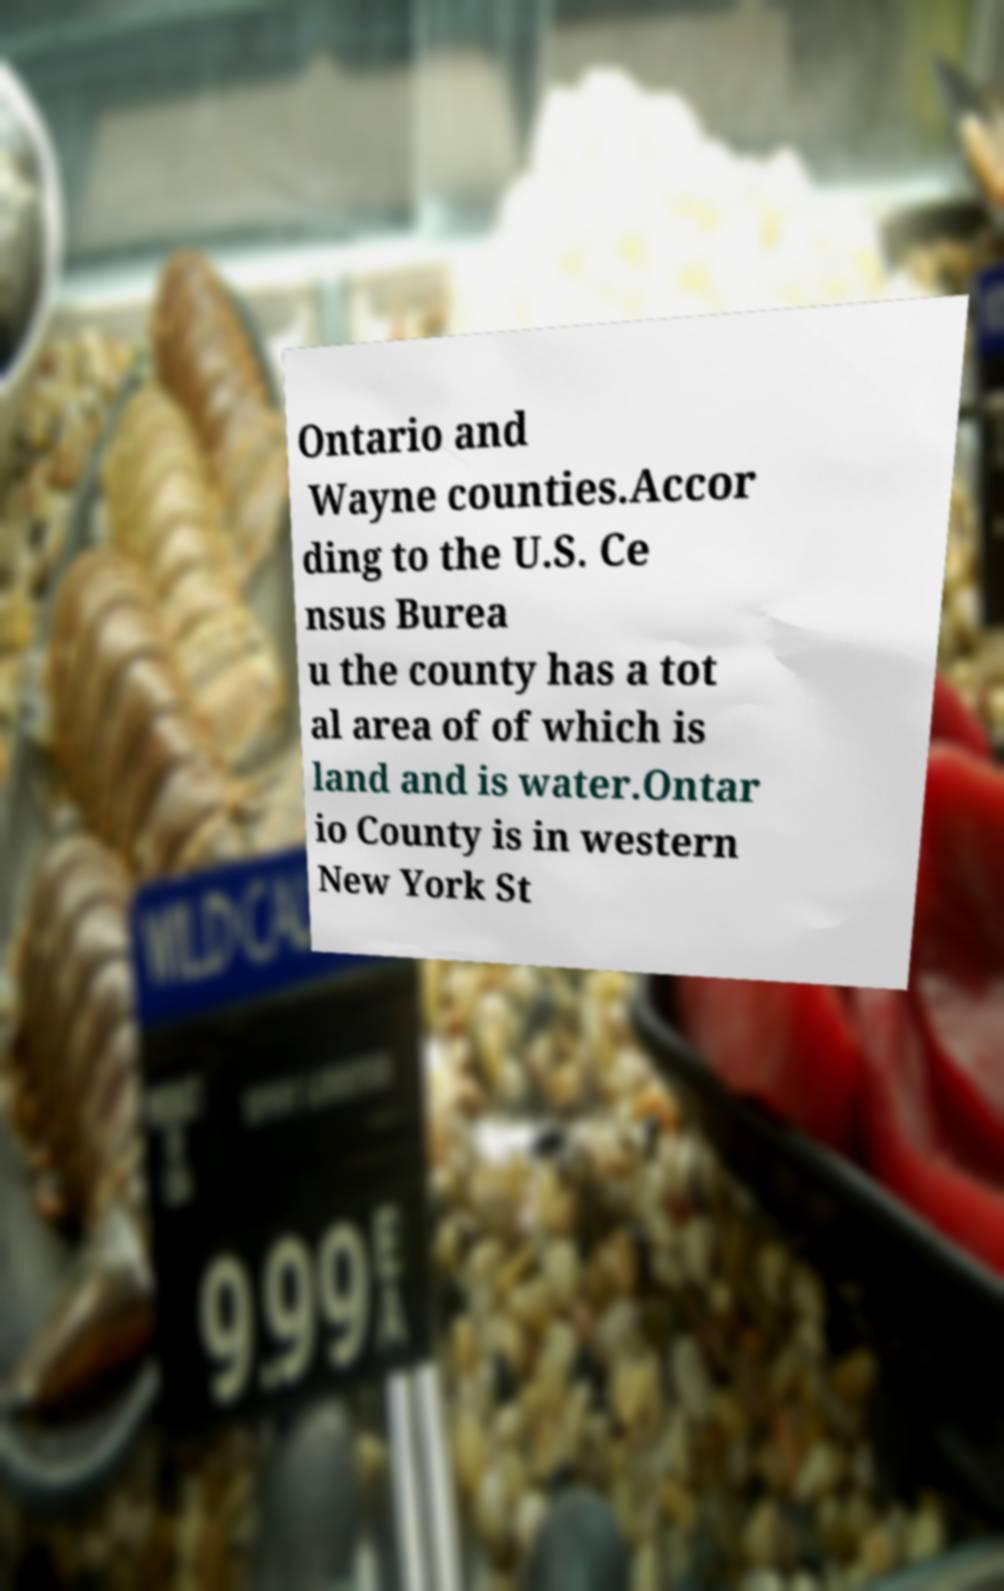Can you accurately transcribe the text from the provided image for me? Ontario and Wayne counties.Accor ding to the U.S. Ce nsus Burea u the county has a tot al area of of which is land and is water.Ontar io County is in western New York St 